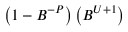<formula> <loc_0><loc_0><loc_500><loc_500>\left ( 1 - B ^ { - P } \right ) \left ( B ^ { U + 1 } \right )</formula> 